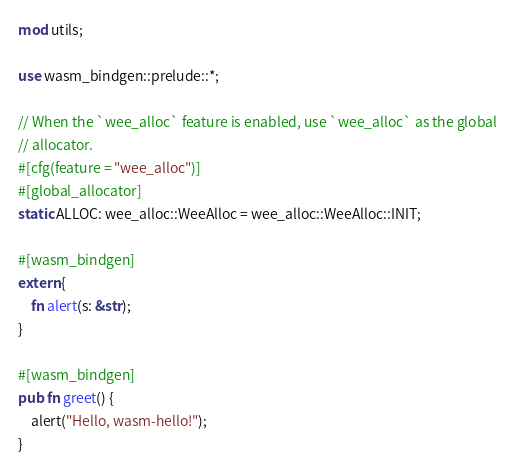Convert code to text. <code><loc_0><loc_0><loc_500><loc_500><_Rust_>mod utils;

use wasm_bindgen::prelude::*;

// When the `wee_alloc` feature is enabled, use `wee_alloc` as the global
// allocator.
#[cfg(feature = "wee_alloc")]
#[global_allocator]
static ALLOC: wee_alloc::WeeAlloc = wee_alloc::WeeAlloc::INIT;

#[wasm_bindgen]
extern {
    fn alert(s: &str);
}

#[wasm_bindgen]
pub fn greet() {
    alert("Hello, wasm-hello!");
}
</code> 